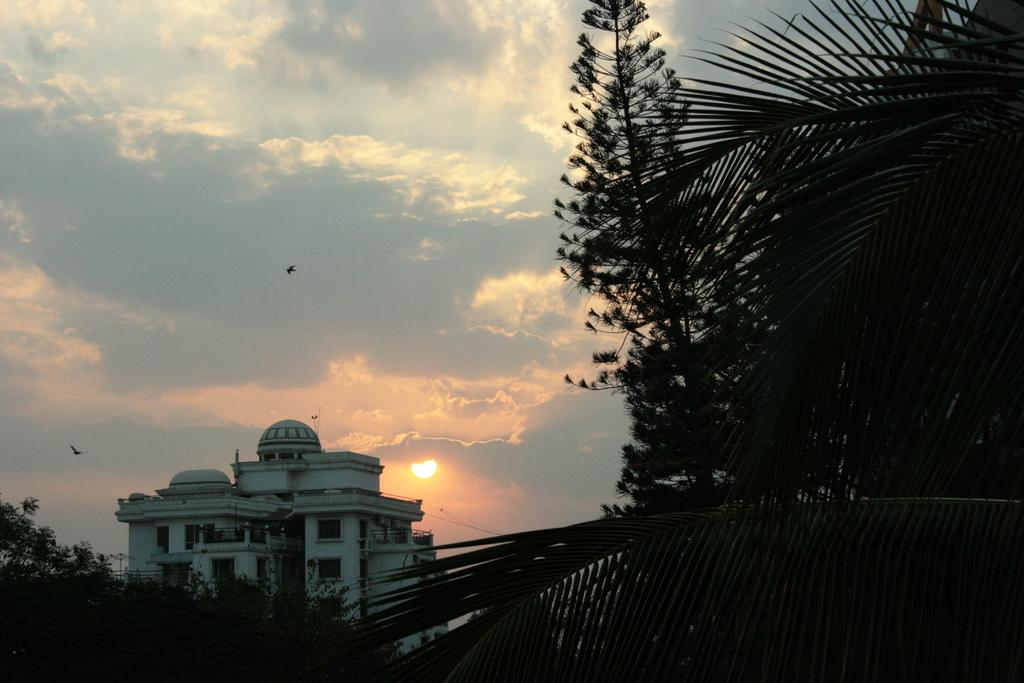What type of structure is present in the image? There is a building in the image. What other natural elements can be seen in the image? There are trees in the image. What is visible at the top of the image? The sky is visible at the top of the image. What can be observed in the sky? There are clouds and the sun visible in the sky. Are there any animals present in the image? Yes, birds are flying in the sky. What type of agreement is being signed by the birds in the image? There are no birds signing any agreements in the image; they are simply flying in the sky. 